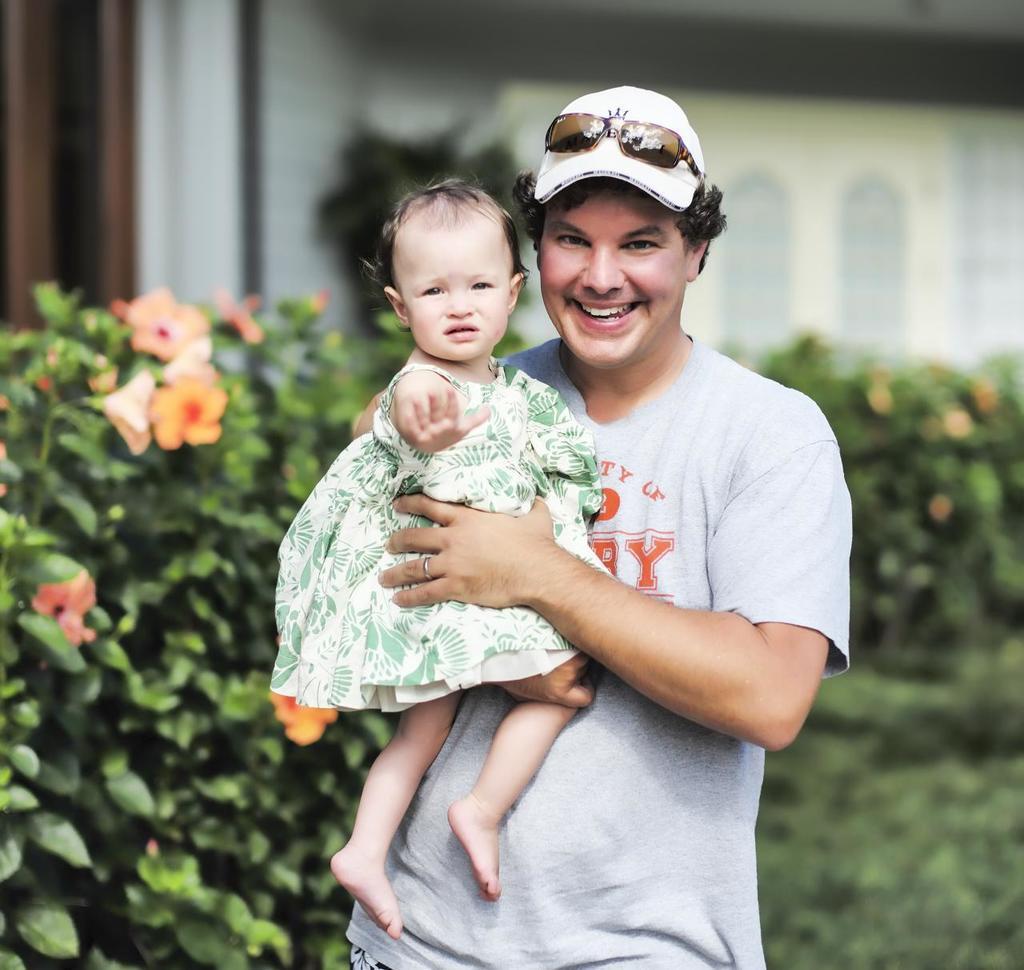Describe this image in one or two sentences. In this image, I can see a man standing and smiling. He is carrying a girl. Behind the man, there are plants. There is a blurred background. 